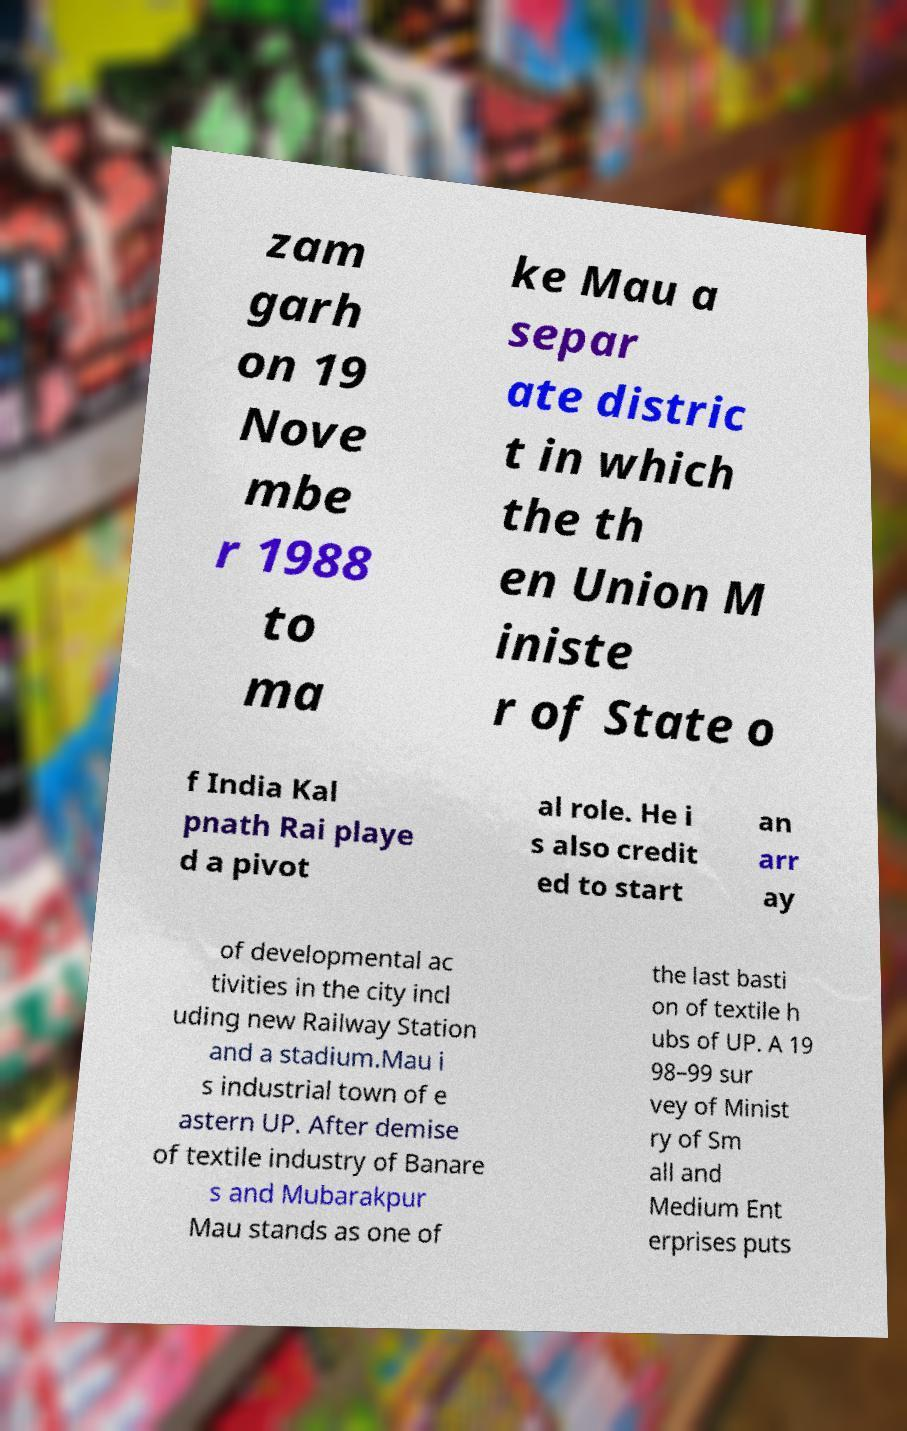Please identify and transcribe the text found in this image. zam garh on 19 Nove mbe r 1988 to ma ke Mau a separ ate distric t in which the th en Union M iniste r of State o f India Kal pnath Rai playe d a pivot al role. He i s also credit ed to start an arr ay of developmental ac tivities in the city incl uding new Railway Station and a stadium.Mau i s industrial town of e astern UP. After demise of textile industry of Banare s and Mubarakpur Mau stands as one of the last basti on of textile h ubs of UP. A 19 98–99 sur vey of Minist ry of Sm all and Medium Ent erprises puts 